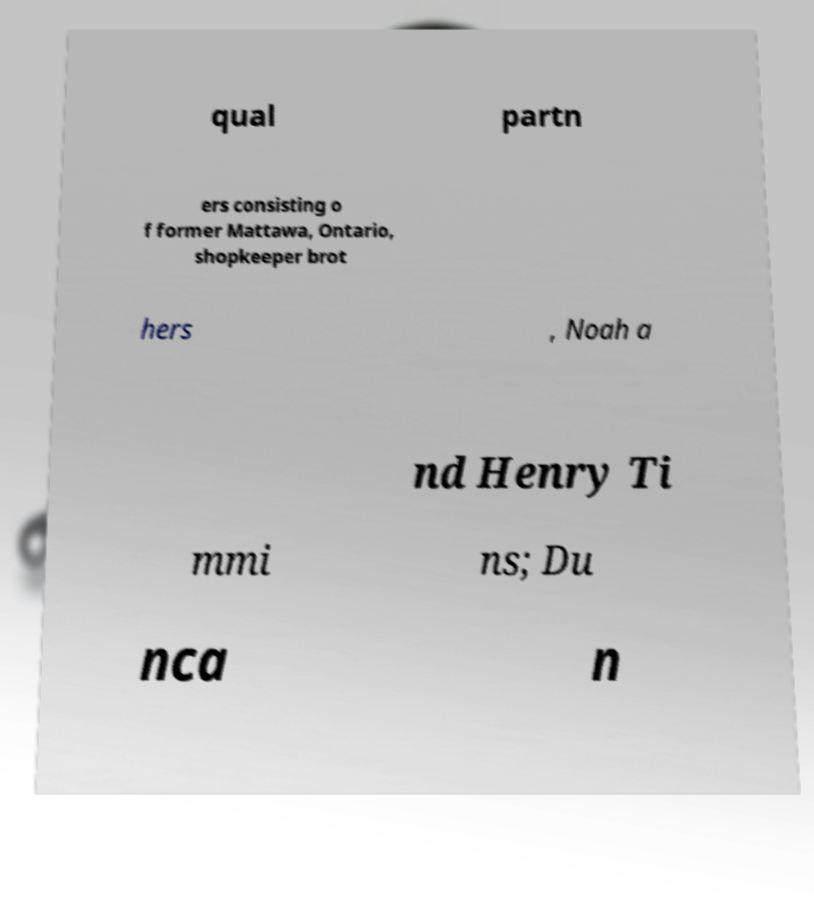There's text embedded in this image that I need extracted. Can you transcribe it verbatim? qual partn ers consisting o f former Mattawa, Ontario, shopkeeper brot hers , Noah a nd Henry Ti mmi ns; Du nca n 